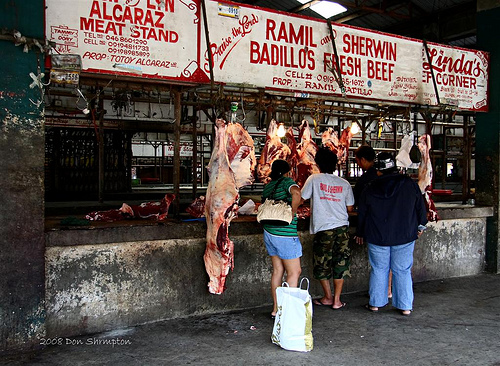<image>
Is the jacket on the man? No. The jacket is not positioned on the man. They may be near each other, but the jacket is not supported by or resting on top of the man. 